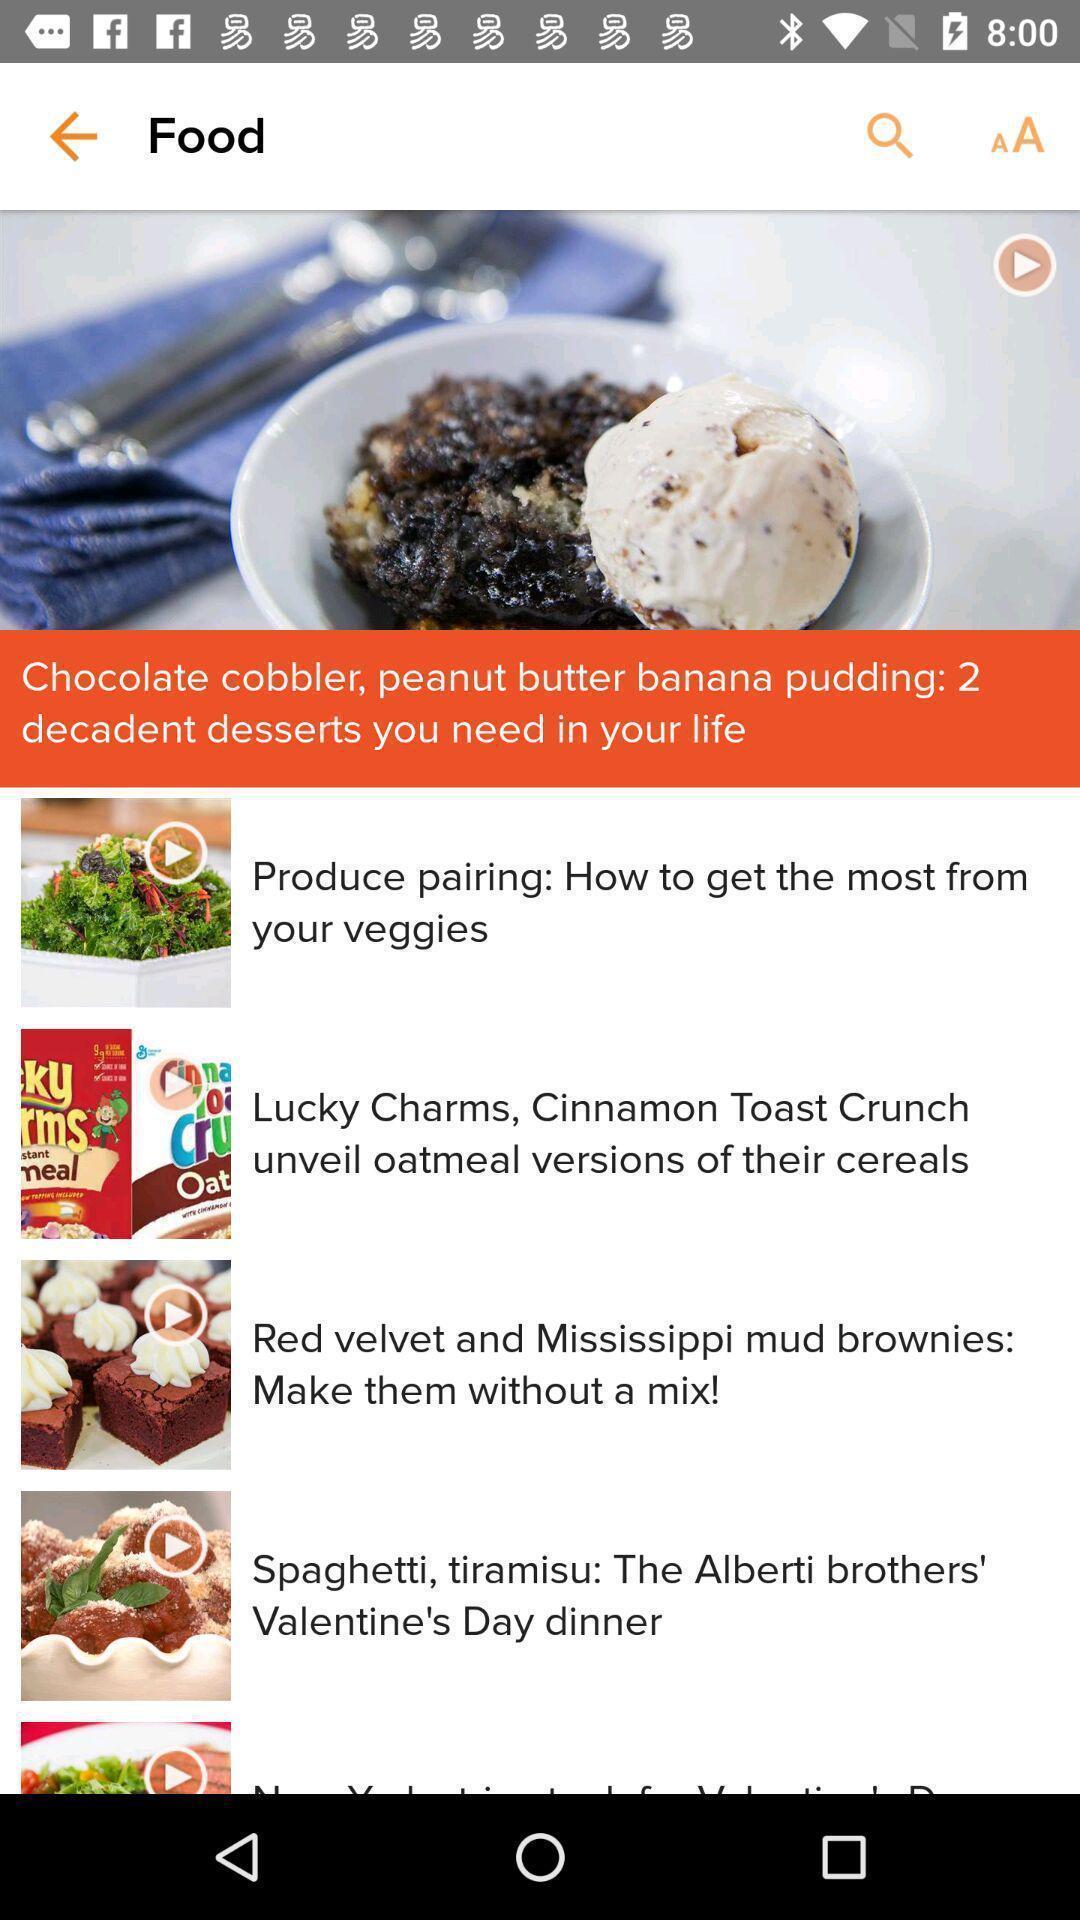Provide a detailed account of this screenshot. Page displaying information about a food application. 